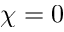<formula> <loc_0><loc_0><loc_500><loc_500>\chi = 0</formula> 